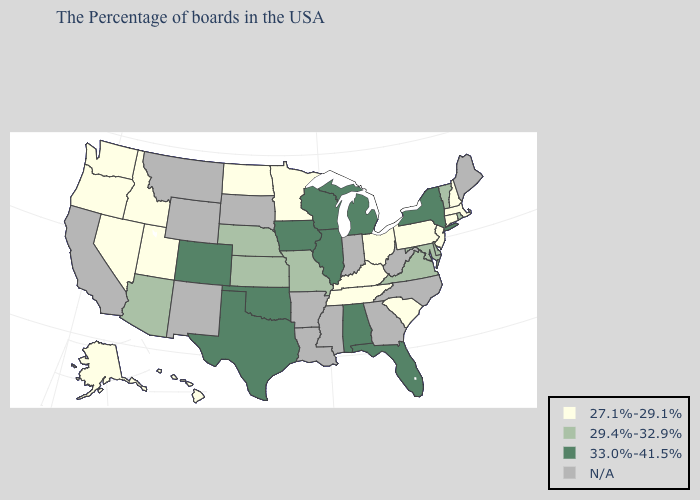Name the states that have a value in the range 29.4%-32.9%?
Write a very short answer. Rhode Island, Vermont, Delaware, Maryland, Virginia, Missouri, Kansas, Nebraska, Arizona. What is the value of New Hampshire?
Be succinct. 27.1%-29.1%. Which states have the lowest value in the South?
Keep it brief. South Carolina, Kentucky, Tennessee. Name the states that have a value in the range 33.0%-41.5%?
Be succinct. New York, Florida, Michigan, Alabama, Wisconsin, Illinois, Iowa, Oklahoma, Texas, Colorado. Among the states that border Alabama , which have the highest value?
Give a very brief answer. Florida. Name the states that have a value in the range 33.0%-41.5%?
Concise answer only. New York, Florida, Michigan, Alabama, Wisconsin, Illinois, Iowa, Oklahoma, Texas, Colorado. How many symbols are there in the legend?
Quick response, please. 4. What is the value of Oklahoma?
Give a very brief answer. 33.0%-41.5%. Does the first symbol in the legend represent the smallest category?
Short answer required. Yes. Which states have the lowest value in the South?
Be succinct. South Carolina, Kentucky, Tennessee. How many symbols are there in the legend?
Short answer required. 4. Is the legend a continuous bar?
Keep it brief. No. Does Hawaii have the highest value in the USA?
Be succinct. No. Among the states that border Virginia , which have the lowest value?
Short answer required. Kentucky, Tennessee. 